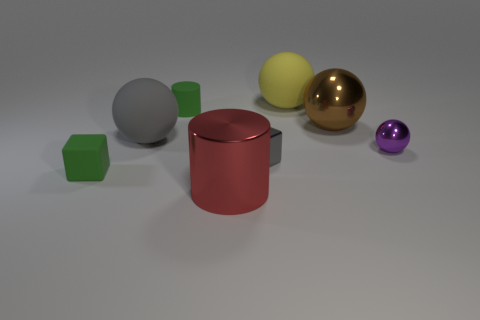Aside from the green block, which object seems to be the smallest? Besides the green block, the purple sphere appears to be the smallest object in the image. What purpose might these objects serve if they were part of a larger model? If these objects were part of a larger model, they could represent various elements in a conceptual or educational build, such as atoms in a molecular structure, game pieces for an educational purpose, or components within a visual demonstration of geometry. 